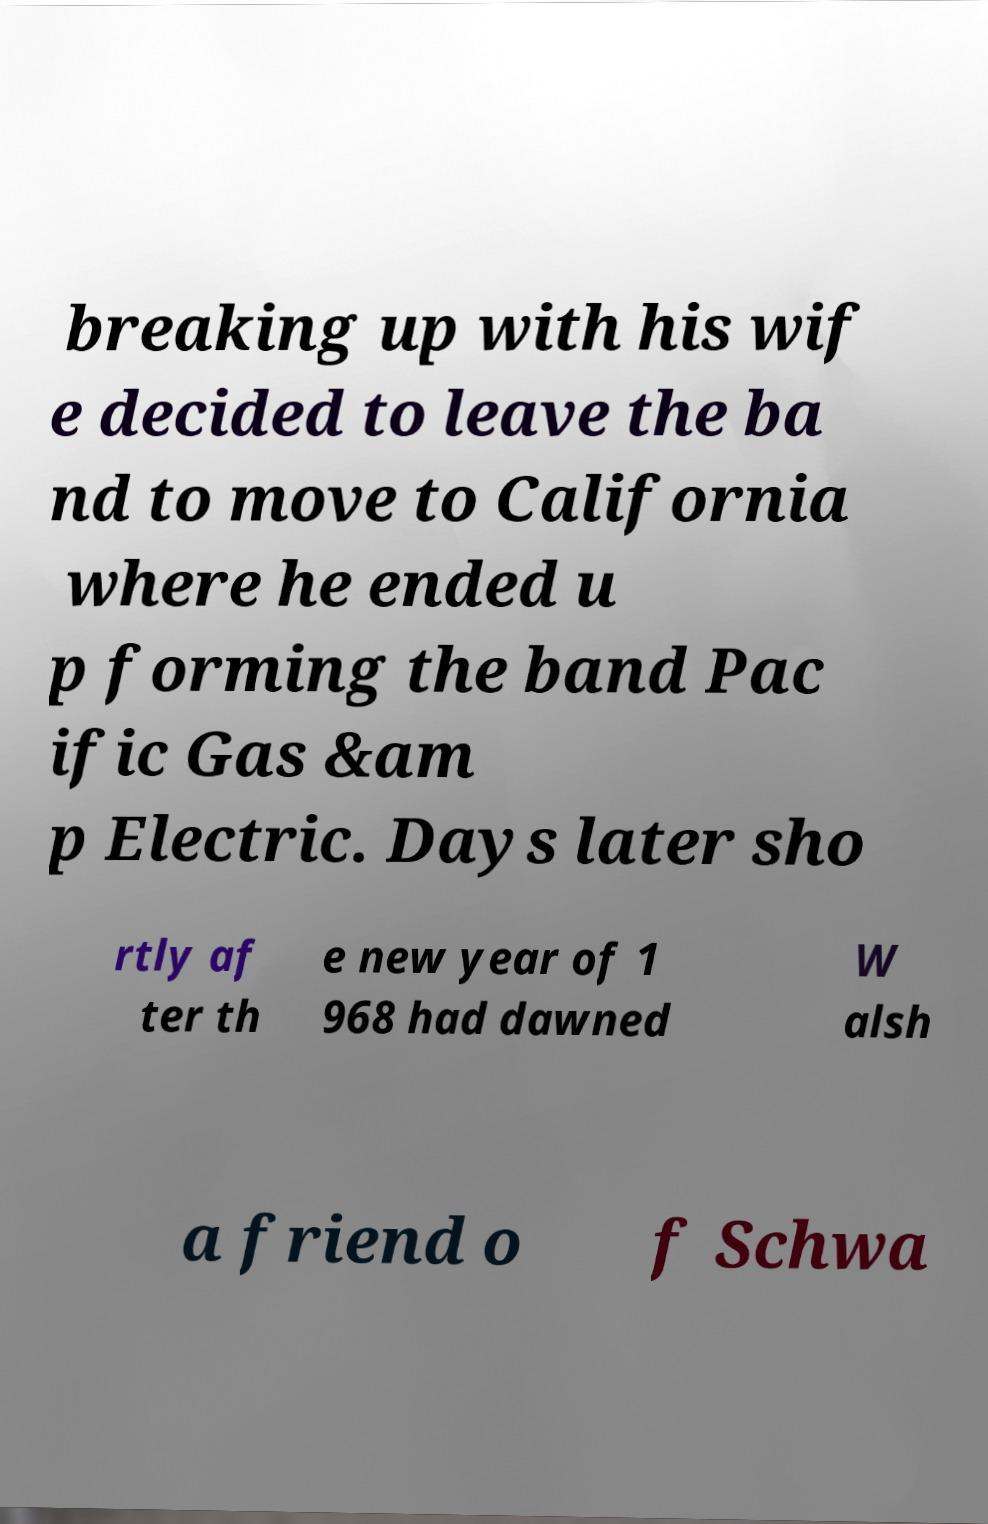Could you assist in decoding the text presented in this image and type it out clearly? breaking up with his wif e decided to leave the ba nd to move to California where he ended u p forming the band Pac ific Gas &am p Electric. Days later sho rtly af ter th e new year of 1 968 had dawned W alsh a friend o f Schwa 